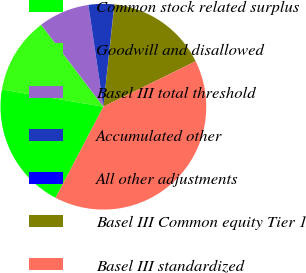Convert chart. <chart><loc_0><loc_0><loc_500><loc_500><pie_chart><fcel>Common stock related surplus<fcel>Goodwill and disallowed<fcel>Basel III total threshold<fcel>Accumulated other<fcel>All other adjustments<fcel>Basel III Common equity Tier 1<fcel>Basel III standardized<nl><fcel>19.99%<fcel>12.0%<fcel>8.01%<fcel>4.02%<fcel>0.03%<fcel>16.0%<fcel>39.95%<nl></chart> 